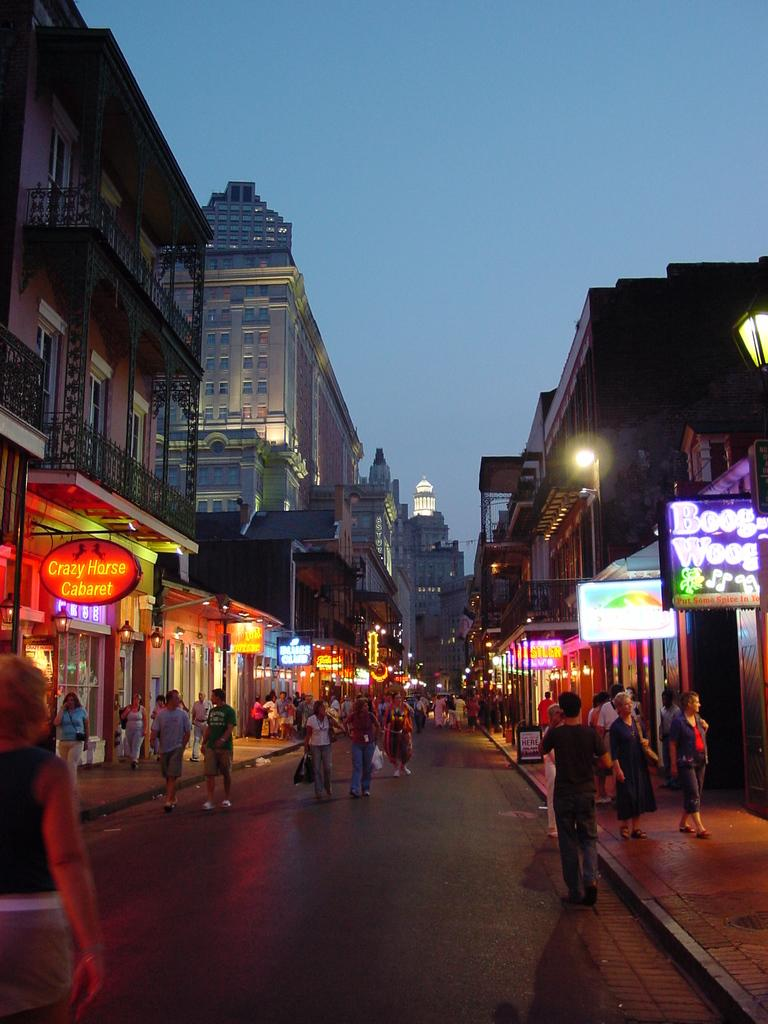What is the main focus of the image? The main focus of the image is the people in the center. What else can be seen in the image besides the people? There are stalls, posters, buildings, and lamps in the image. What type of grass is growing around the people in the image? There is no grass visible in the image. How many cherries can be seen on the posters in the image? There are no cherries present in the image. 